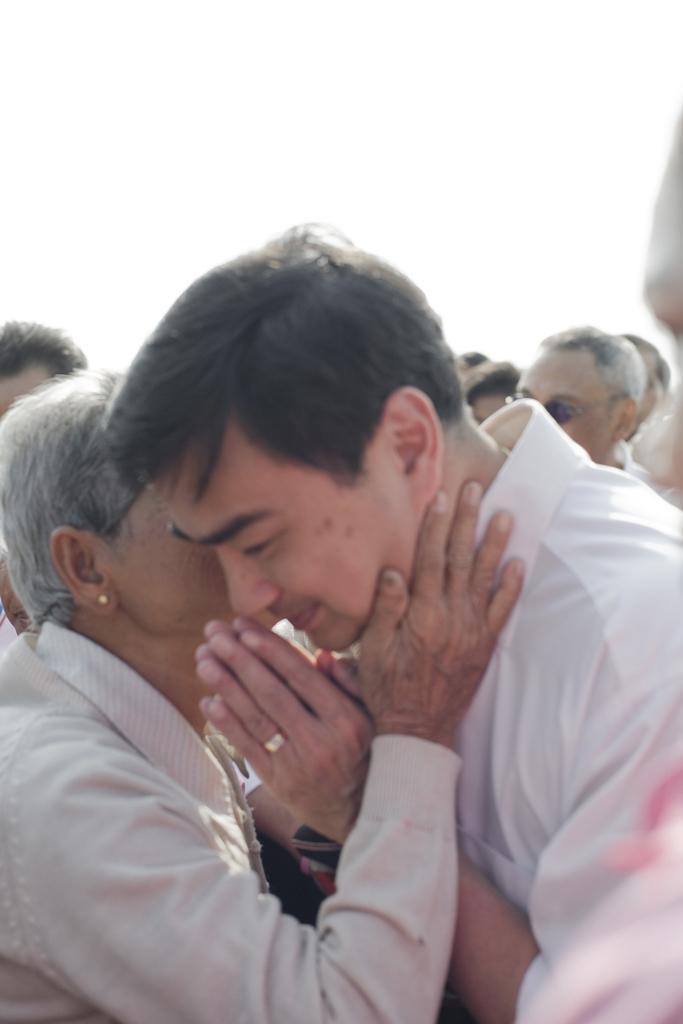In one or two sentences, can you explain what this image depicts? On the left side, there is a person in a cream color shirt, placing a hand on the neck of a person, who is in a white colored shirt and has joined hands together. In the background, there are other persons and there are clouds in the sky. 